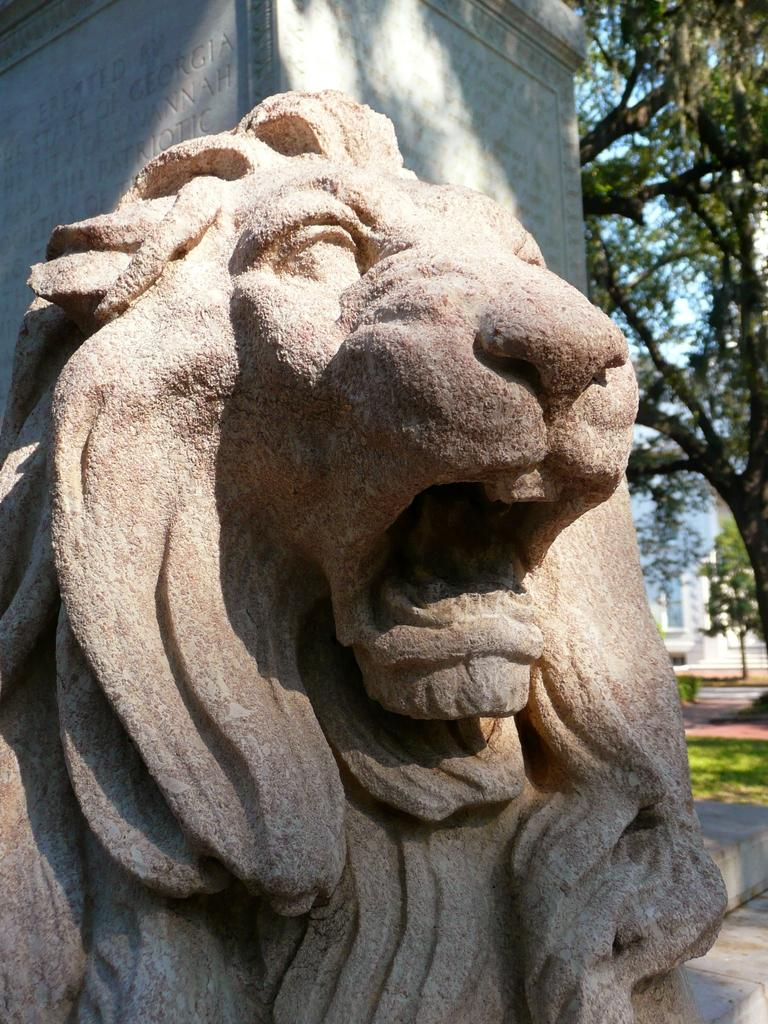What type of animal is depicted in the stone sculpture in the image? There is a lion stone sculpture in the image. What is located behind the lion sculpture? There is a stone with wordings behind the sculpture. What type of vegetation can be seen in the image? There are trees visible in the image. What type of surface is visible beneath the lion sculpture? There is a grass surface in the image. How does the island contribute to the lion sculpture's habitat in the image? There is no island present in the image; it features a lion stone sculpture, a stone with wordings, trees, and a grass surface. 